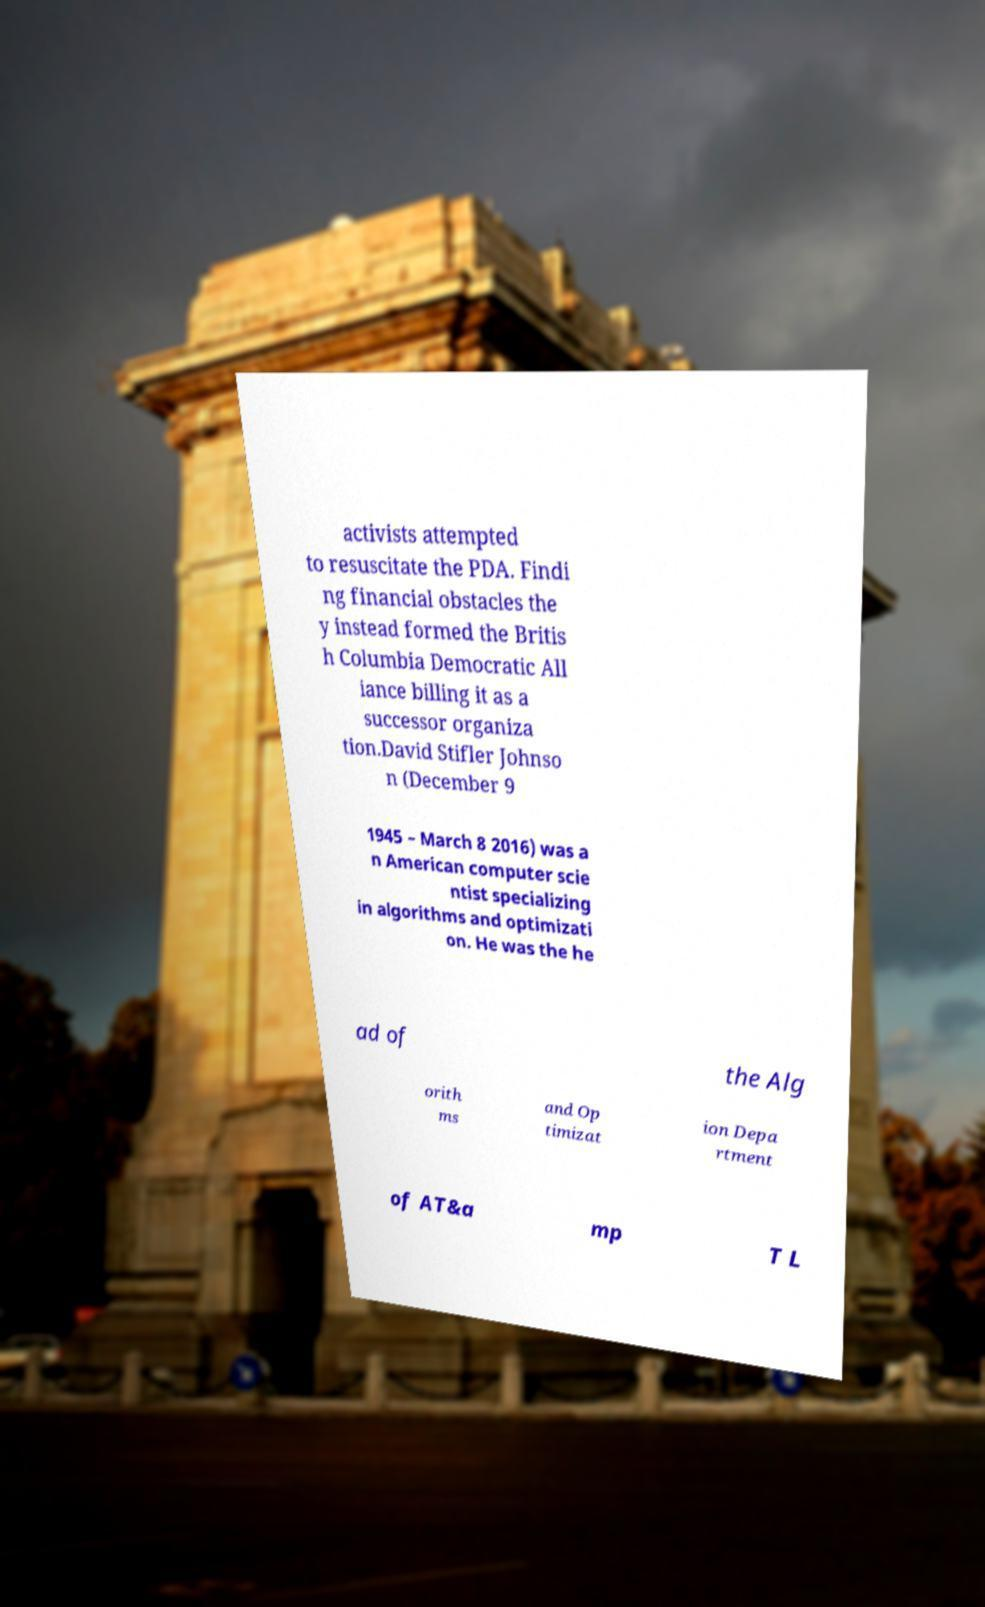Could you extract and type out the text from this image? activists attempted to resuscitate the PDA. Findi ng financial obstacles the y instead formed the Britis h Columbia Democratic All iance billing it as a successor organiza tion.David Stifler Johnso n (December 9 1945 – March 8 2016) was a n American computer scie ntist specializing in algorithms and optimizati on. He was the he ad of the Alg orith ms and Op timizat ion Depa rtment of AT&a mp T L 